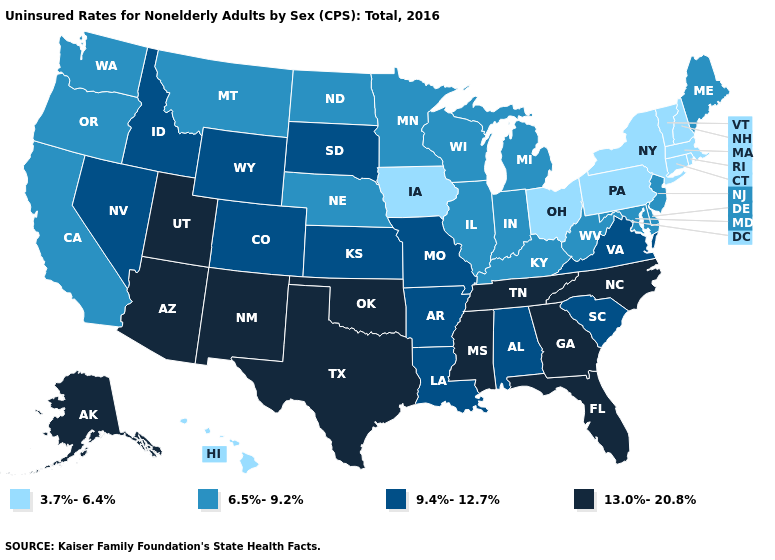Which states have the highest value in the USA?
Quick response, please. Alaska, Arizona, Florida, Georgia, Mississippi, New Mexico, North Carolina, Oklahoma, Tennessee, Texas, Utah. Among the states that border Illinois , which have the lowest value?
Short answer required. Iowa. Does Tennessee have the same value as Pennsylvania?
Give a very brief answer. No. What is the value of Virginia?
Concise answer only. 9.4%-12.7%. What is the value of Arkansas?
Give a very brief answer. 9.4%-12.7%. Among the states that border Wisconsin , does Iowa have the lowest value?
Quick response, please. Yes. What is the lowest value in the USA?
Concise answer only. 3.7%-6.4%. Is the legend a continuous bar?
Be succinct. No. Does Kentucky have the lowest value in the South?
Give a very brief answer. Yes. Name the states that have a value in the range 6.5%-9.2%?
Concise answer only. California, Delaware, Illinois, Indiana, Kentucky, Maine, Maryland, Michigan, Minnesota, Montana, Nebraska, New Jersey, North Dakota, Oregon, Washington, West Virginia, Wisconsin. What is the highest value in the Northeast ?
Be succinct. 6.5%-9.2%. Does the map have missing data?
Concise answer only. No. Name the states that have a value in the range 9.4%-12.7%?
Answer briefly. Alabama, Arkansas, Colorado, Idaho, Kansas, Louisiana, Missouri, Nevada, South Carolina, South Dakota, Virginia, Wyoming. What is the value of Tennessee?
Answer briefly. 13.0%-20.8%. 